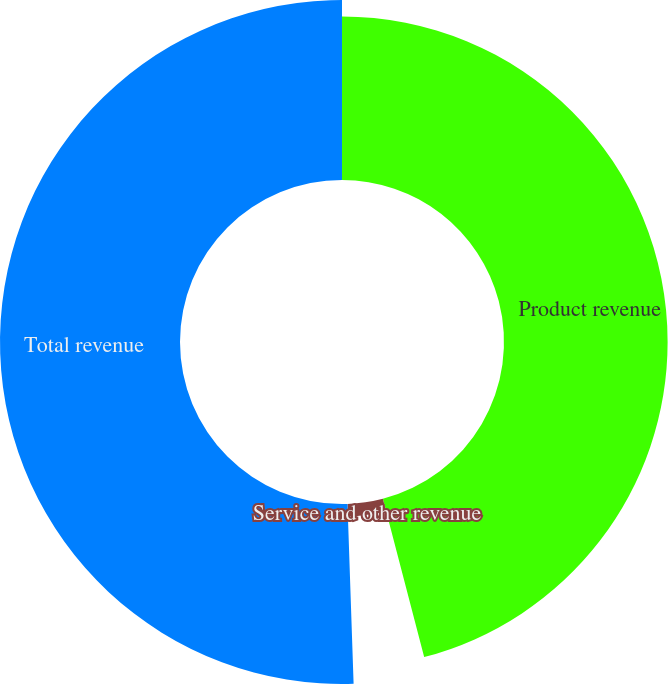Convert chart to OTSL. <chart><loc_0><loc_0><loc_500><loc_500><pie_chart><fcel>Product revenue<fcel>Service and other revenue<fcel>Total revenue<nl><fcel>45.94%<fcel>3.52%<fcel>50.54%<nl></chart> 